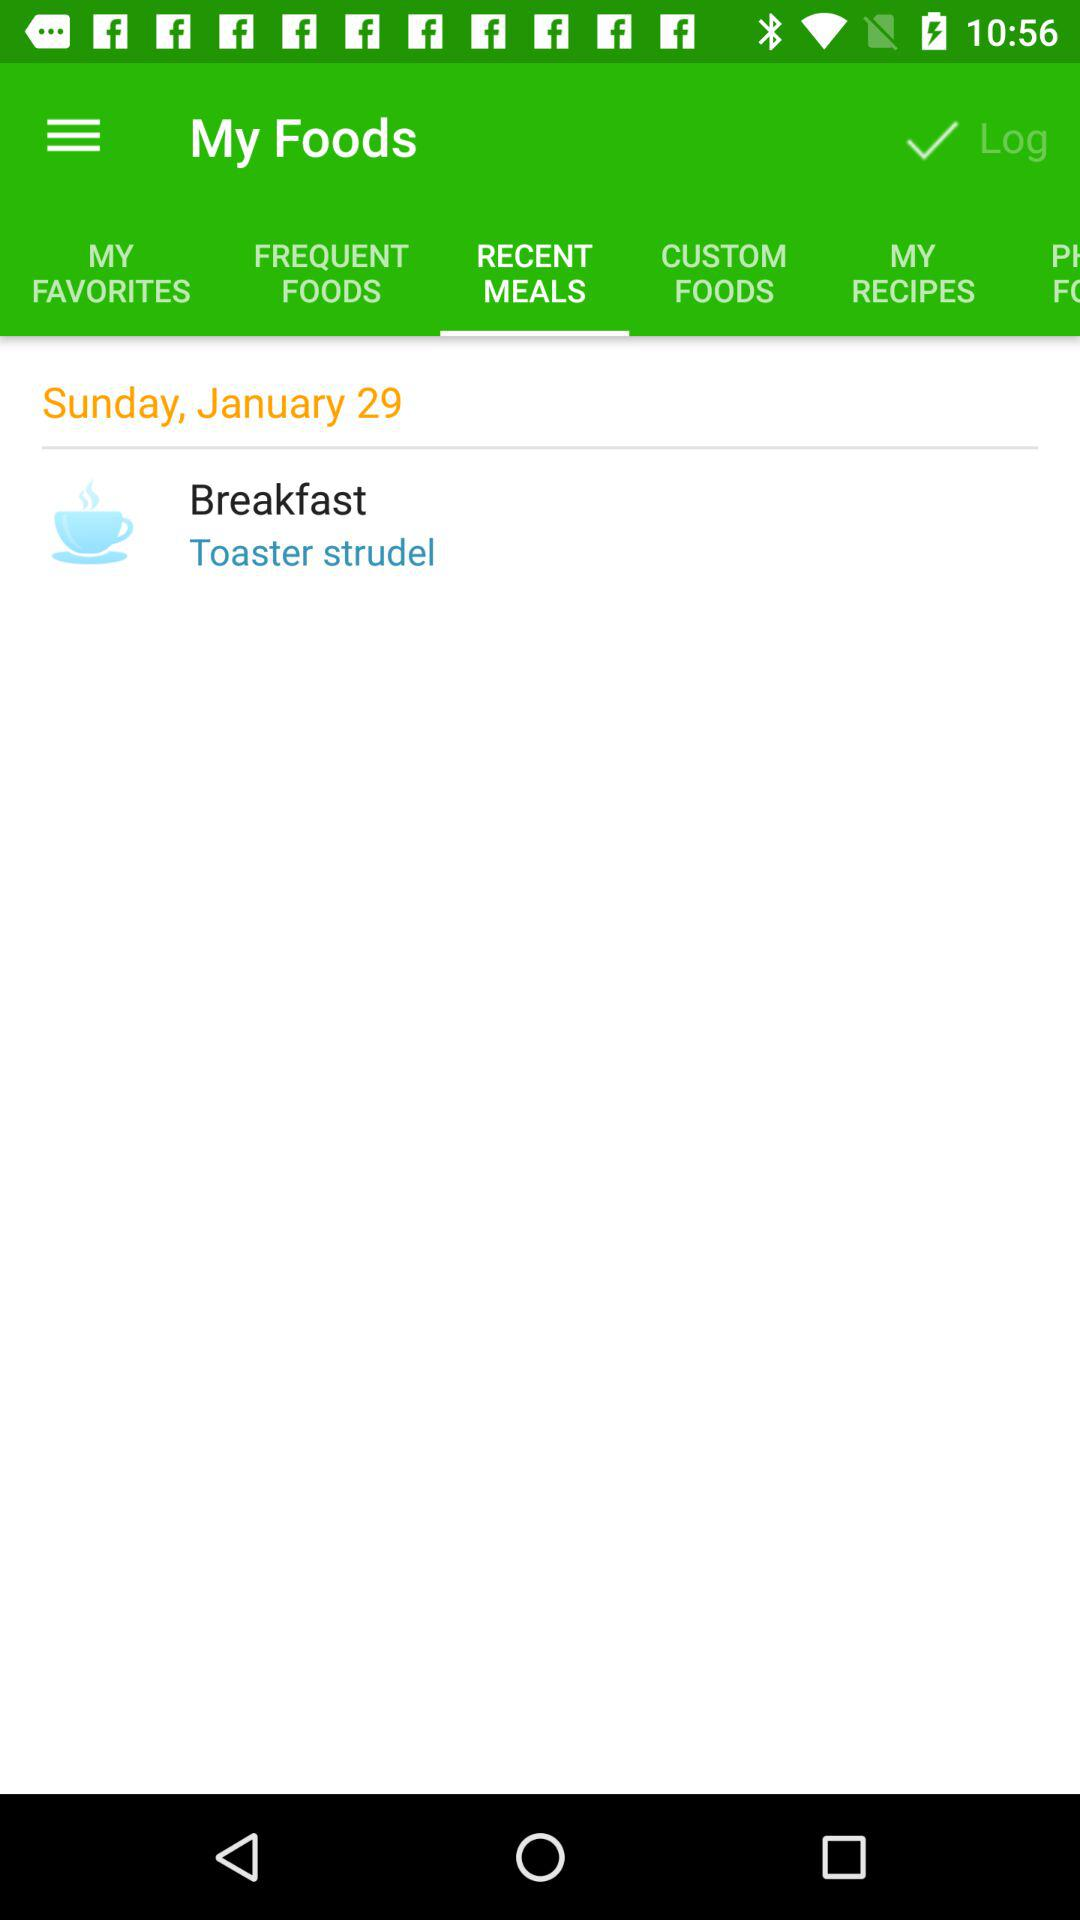Which tab is selected? The selected tab is "RECENT MEALS". 